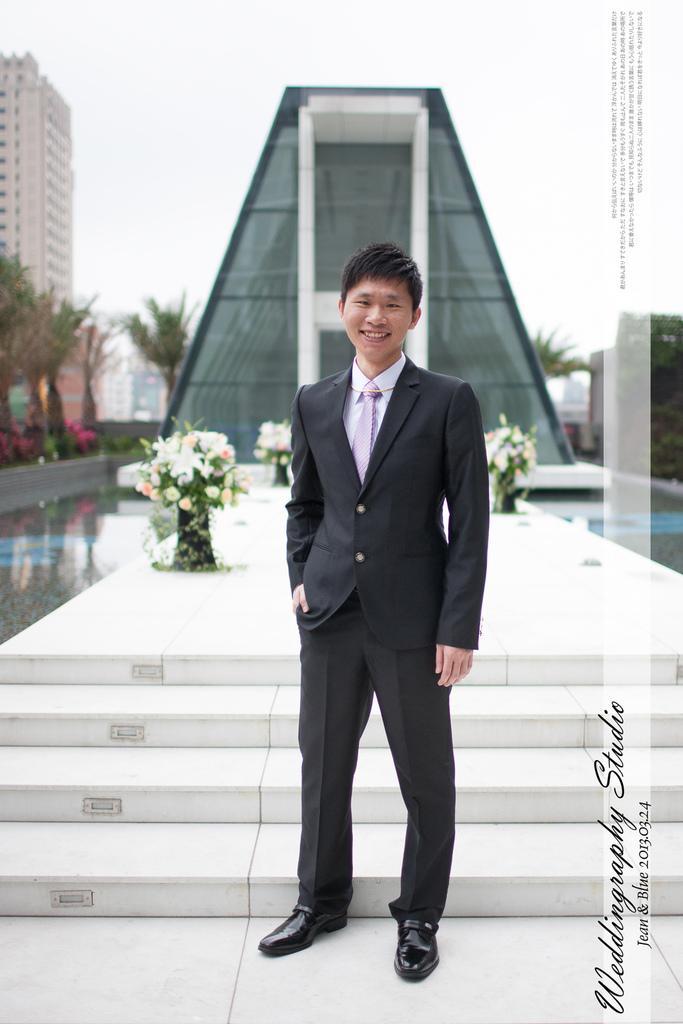Can you describe this image briefly? In this picture we can see a man, he is smiling, behind to him we can see few flowers, buildings, trees and water. 